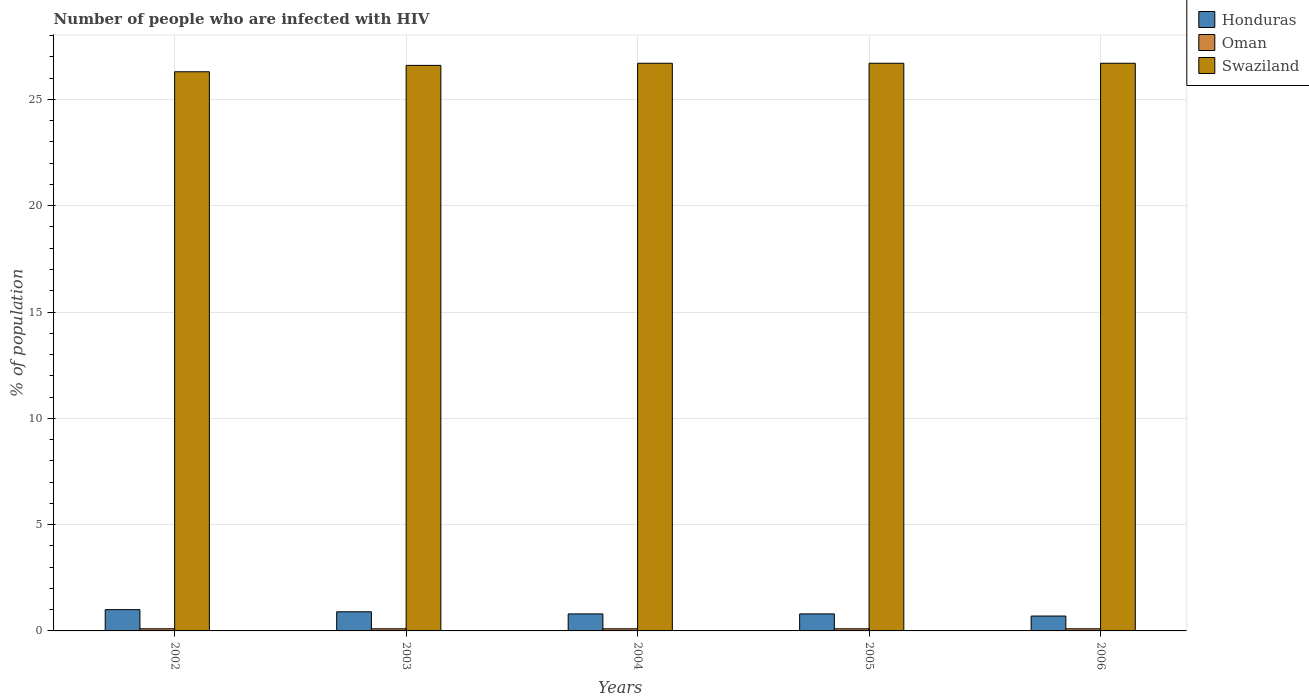How many different coloured bars are there?
Your response must be concise. 3. How many groups of bars are there?
Offer a terse response. 5. Are the number of bars per tick equal to the number of legend labels?
Provide a succinct answer. Yes. Are the number of bars on each tick of the X-axis equal?
Provide a succinct answer. Yes. How many bars are there on the 4th tick from the right?
Make the answer very short. 3. In how many cases, is the number of bars for a given year not equal to the number of legend labels?
Give a very brief answer. 0. Across all years, what is the maximum percentage of HIV infected population in in Honduras?
Give a very brief answer. 1. In which year was the percentage of HIV infected population in in Honduras maximum?
Your response must be concise. 2002. What is the total percentage of HIV infected population in in Oman in the graph?
Ensure brevity in your answer.  0.5. What is the difference between the percentage of HIV infected population in in Swaziland in 2005 and the percentage of HIV infected population in in Honduras in 2002?
Your answer should be very brief. 25.7. What is the average percentage of HIV infected population in in Swaziland per year?
Provide a short and direct response. 26.6. In the year 2004, what is the difference between the percentage of HIV infected population in in Honduras and percentage of HIV infected population in in Swaziland?
Provide a short and direct response. -25.9. In how many years, is the percentage of HIV infected population in in Swaziland greater than 12 %?
Your answer should be very brief. 5. What is the ratio of the percentage of HIV infected population in in Honduras in 2003 to that in 2005?
Ensure brevity in your answer.  1.12. Is the difference between the percentage of HIV infected population in in Honduras in 2002 and 2005 greater than the difference between the percentage of HIV infected population in in Swaziland in 2002 and 2005?
Make the answer very short. Yes. What is the difference between the highest and the second highest percentage of HIV infected population in in Honduras?
Your answer should be very brief. 0.1. What is the difference between the highest and the lowest percentage of HIV infected population in in Swaziland?
Ensure brevity in your answer.  0.4. What does the 1st bar from the left in 2005 represents?
Keep it short and to the point. Honduras. What does the 1st bar from the right in 2004 represents?
Offer a terse response. Swaziland. Is it the case that in every year, the sum of the percentage of HIV infected population in in Honduras and percentage of HIV infected population in in Swaziland is greater than the percentage of HIV infected population in in Oman?
Your answer should be very brief. Yes. How many bars are there?
Give a very brief answer. 15. How many years are there in the graph?
Give a very brief answer. 5. Are the values on the major ticks of Y-axis written in scientific E-notation?
Ensure brevity in your answer.  No. Does the graph contain any zero values?
Offer a terse response. No. Where does the legend appear in the graph?
Your response must be concise. Top right. How many legend labels are there?
Offer a very short reply. 3. What is the title of the graph?
Make the answer very short. Number of people who are infected with HIV. Does "Sweden" appear as one of the legend labels in the graph?
Ensure brevity in your answer.  No. What is the label or title of the X-axis?
Offer a very short reply. Years. What is the label or title of the Y-axis?
Give a very brief answer. % of population. What is the % of population of Swaziland in 2002?
Your answer should be very brief. 26.3. What is the % of population in Honduras in 2003?
Provide a short and direct response. 0.9. What is the % of population of Oman in 2003?
Your response must be concise. 0.1. What is the % of population in Swaziland in 2003?
Offer a terse response. 26.6. What is the % of population of Oman in 2004?
Your answer should be compact. 0.1. What is the % of population in Swaziland in 2004?
Make the answer very short. 26.7. What is the % of population in Swaziland in 2005?
Keep it short and to the point. 26.7. What is the % of population in Honduras in 2006?
Keep it short and to the point. 0.7. What is the % of population in Swaziland in 2006?
Your answer should be very brief. 26.7. Across all years, what is the maximum % of population of Oman?
Your answer should be compact. 0.1. Across all years, what is the maximum % of population in Swaziland?
Your response must be concise. 26.7. Across all years, what is the minimum % of population of Honduras?
Give a very brief answer. 0.7. Across all years, what is the minimum % of population of Swaziland?
Give a very brief answer. 26.3. What is the total % of population of Swaziland in the graph?
Provide a short and direct response. 133. What is the difference between the % of population of Oman in 2002 and that in 2003?
Provide a succinct answer. 0. What is the difference between the % of population in Swaziland in 2002 and that in 2003?
Provide a short and direct response. -0.3. What is the difference between the % of population in Honduras in 2002 and that in 2004?
Provide a succinct answer. 0.2. What is the difference between the % of population of Oman in 2002 and that in 2004?
Provide a short and direct response. 0. What is the difference between the % of population of Swaziland in 2002 and that in 2004?
Provide a succinct answer. -0.4. What is the difference between the % of population in Honduras in 2002 and that in 2006?
Give a very brief answer. 0.3. What is the difference between the % of population in Oman in 2002 and that in 2006?
Your answer should be very brief. 0. What is the difference between the % of population of Honduras in 2003 and that in 2004?
Ensure brevity in your answer.  0.1. What is the difference between the % of population of Oman in 2003 and that in 2004?
Provide a succinct answer. 0. What is the difference between the % of population in Swaziland in 2003 and that in 2004?
Ensure brevity in your answer.  -0.1. What is the difference between the % of population in Oman in 2003 and that in 2005?
Your response must be concise. 0. What is the difference between the % of population in Honduras in 2003 and that in 2006?
Make the answer very short. 0.2. What is the difference between the % of population of Honduras in 2004 and that in 2005?
Offer a very short reply. 0. What is the difference between the % of population of Oman in 2005 and that in 2006?
Offer a terse response. 0. What is the difference between the % of population in Swaziland in 2005 and that in 2006?
Keep it short and to the point. 0. What is the difference between the % of population in Honduras in 2002 and the % of population in Oman in 2003?
Make the answer very short. 0.9. What is the difference between the % of population in Honduras in 2002 and the % of population in Swaziland in 2003?
Ensure brevity in your answer.  -25.6. What is the difference between the % of population in Oman in 2002 and the % of population in Swaziland in 2003?
Make the answer very short. -26.5. What is the difference between the % of population in Honduras in 2002 and the % of population in Oman in 2004?
Make the answer very short. 0.9. What is the difference between the % of population of Honduras in 2002 and the % of population of Swaziland in 2004?
Your response must be concise. -25.7. What is the difference between the % of population in Oman in 2002 and the % of population in Swaziland in 2004?
Ensure brevity in your answer.  -26.6. What is the difference between the % of population in Honduras in 2002 and the % of population in Swaziland in 2005?
Provide a succinct answer. -25.7. What is the difference between the % of population in Oman in 2002 and the % of population in Swaziland in 2005?
Your answer should be compact. -26.6. What is the difference between the % of population of Honduras in 2002 and the % of population of Oman in 2006?
Ensure brevity in your answer.  0.9. What is the difference between the % of population in Honduras in 2002 and the % of population in Swaziland in 2006?
Ensure brevity in your answer.  -25.7. What is the difference between the % of population in Oman in 2002 and the % of population in Swaziland in 2006?
Make the answer very short. -26.6. What is the difference between the % of population of Honduras in 2003 and the % of population of Swaziland in 2004?
Provide a succinct answer. -25.8. What is the difference between the % of population of Oman in 2003 and the % of population of Swaziland in 2004?
Provide a succinct answer. -26.6. What is the difference between the % of population in Honduras in 2003 and the % of population in Swaziland in 2005?
Give a very brief answer. -25.8. What is the difference between the % of population in Oman in 2003 and the % of population in Swaziland in 2005?
Your response must be concise. -26.6. What is the difference between the % of population in Honduras in 2003 and the % of population in Oman in 2006?
Provide a succinct answer. 0.8. What is the difference between the % of population of Honduras in 2003 and the % of population of Swaziland in 2006?
Your answer should be compact. -25.8. What is the difference between the % of population of Oman in 2003 and the % of population of Swaziland in 2006?
Offer a terse response. -26.6. What is the difference between the % of population of Honduras in 2004 and the % of population of Oman in 2005?
Ensure brevity in your answer.  0.7. What is the difference between the % of population in Honduras in 2004 and the % of population in Swaziland in 2005?
Ensure brevity in your answer.  -25.9. What is the difference between the % of population in Oman in 2004 and the % of population in Swaziland in 2005?
Your response must be concise. -26.6. What is the difference between the % of population in Honduras in 2004 and the % of population in Swaziland in 2006?
Make the answer very short. -25.9. What is the difference between the % of population in Oman in 2004 and the % of population in Swaziland in 2006?
Provide a short and direct response. -26.6. What is the difference between the % of population of Honduras in 2005 and the % of population of Swaziland in 2006?
Provide a succinct answer. -25.9. What is the difference between the % of population of Oman in 2005 and the % of population of Swaziland in 2006?
Your answer should be compact. -26.6. What is the average % of population in Honduras per year?
Offer a very short reply. 0.84. What is the average % of population in Swaziland per year?
Your answer should be compact. 26.6. In the year 2002, what is the difference between the % of population of Honduras and % of population of Oman?
Your answer should be very brief. 0.9. In the year 2002, what is the difference between the % of population in Honduras and % of population in Swaziland?
Offer a terse response. -25.3. In the year 2002, what is the difference between the % of population of Oman and % of population of Swaziland?
Your response must be concise. -26.2. In the year 2003, what is the difference between the % of population in Honduras and % of population in Oman?
Keep it short and to the point. 0.8. In the year 2003, what is the difference between the % of population in Honduras and % of population in Swaziland?
Your answer should be very brief. -25.7. In the year 2003, what is the difference between the % of population in Oman and % of population in Swaziland?
Your answer should be compact. -26.5. In the year 2004, what is the difference between the % of population in Honduras and % of population in Swaziland?
Your answer should be very brief. -25.9. In the year 2004, what is the difference between the % of population in Oman and % of population in Swaziland?
Your answer should be very brief. -26.6. In the year 2005, what is the difference between the % of population in Honduras and % of population in Swaziland?
Give a very brief answer. -25.9. In the year 2005, what is the difference between the % of population in Oman and % of population in Swaziland?
Your answer should be compact. -26.6. In the year 2006, what is the difference between the % of population of Oman and % of population of Swaziland?
Your response must be concise. -26.6. What is the ratio of the % of population in Oman in 2002 to that in 2003?
Provide a short and direct response. 1. What is the ratio of the % of population in Swaziland in 2002 to that in 2003?
Provide a short and direct response. 0.99. What is the ratio of the % of population of Honduras in 2002 to that in 2004?
Your response must be concise. 1.25. What is the ratio of the % of population in Oman in 2002 to that in 2004?
Make the answer very short. 1. What is the ratio of the % of population of Swaziland in 2002 to that in 2004?
Provide a short and direct response. 0.98. What is the ratio of the % of population in Oman in 2002 to that in 2005?
Ensure brevity in your answer.  1. What is the ratio of the % of population in Swaziland in 2002 to that in 2005?
Offer a terse response. 0.98. What is the ratio of the % of population of Honduras in 2002 to that in 2006?
Your answer should be compact. 1.43. What is the ratio of the % of population in Swaziland in 2002 to that in 2006?
Offer a very short reply. 0.98. What is the ratio of the % of population in Honduras in 2003 to that in 2004?
Give a very brief answer. 1.12. What is the ratio of the % of population of Oman in 2003 to that in 2004?
Offer a terse response. 1. What is the ratio of the % of population in Swaziland in 2003 to that in 2005?
Provide a short and direct response. 1. What is the ratio of the % of population of Honduras in 2003 to that in 2006?
Ensure brevity in your answer.  1.29. What is the ratio of the % of population in Swaziland in 2003 to that in 2006?
Offer a very short reply. 1. What is the ratio of the % of population of Oman in 2004 to that in 2005?
Offer a terse response. 1. What is the ratio of the % of population in Swaziland in 2004 to that in 2005?
Keep it short and to the point. 1. What is the ratio of the % of population of Swaziland in 2004 to that in 2006?
Provide a succinct answer. 1. What is the ratio of the % of population of Oman in 2005 to that in 2006?
Your response must be concise. 1. What is the difference between the highest and the second highest % of population in Honduras?
Keep it short and to the point. 0.1. What is the difference between the highest and the second highest % of population in Oman?
Give a very brief answer. 0. What is the difference between the highest and the second highest % of population of Swaziland?
Provide a short and direct response. 0. What is the difference between the highest and the lowest % of population in Oman?
Offer a very short reply. 0. 